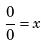Convert formula to latex. <formula><loc_0><loc_0><loc_500><loc_500>\frac { 0 } { 0 } = x</formula> 